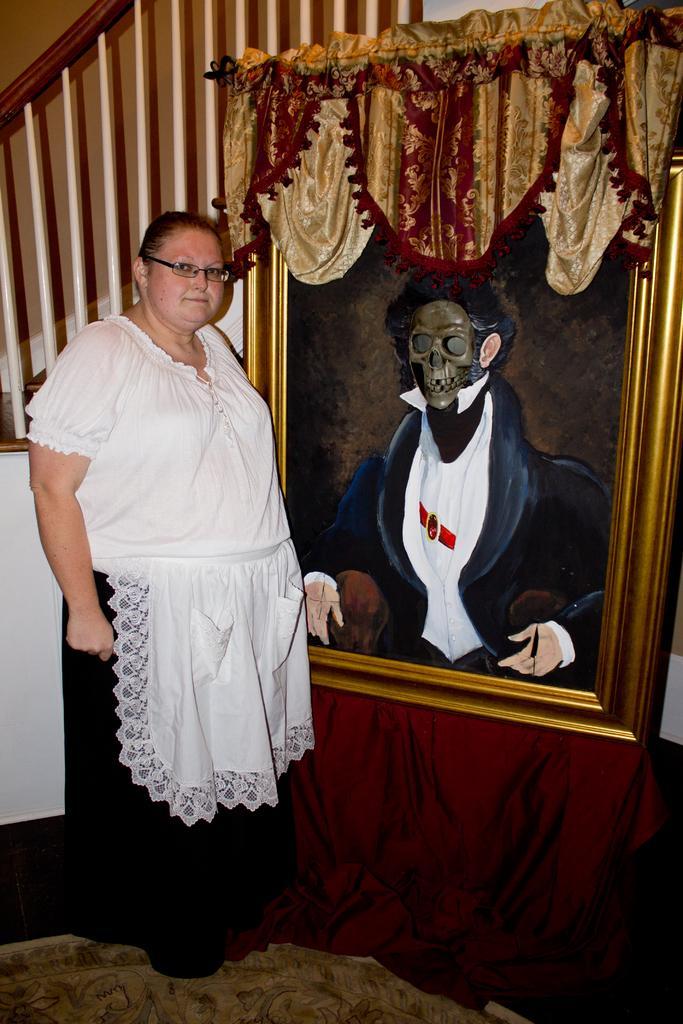How would you summarize this image in a sentence or two? This is the picture of a room. In this image there is a woman standing and there is a painting in the frame and there is frame on the table and the table is covered with red color cloth. At the back there is a staircase and there is a wooden handrail. At the bottom there is a mat. 